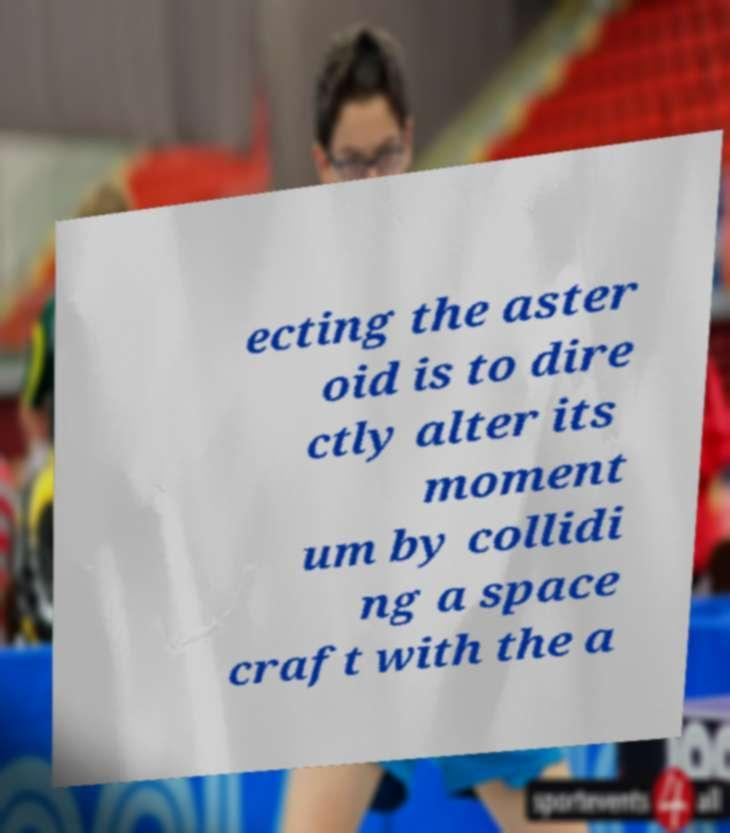Could you extract and type out the text from this image? ecting the aster oid is to dire ctly alter its moment um by collidi ng a space craft with the a 